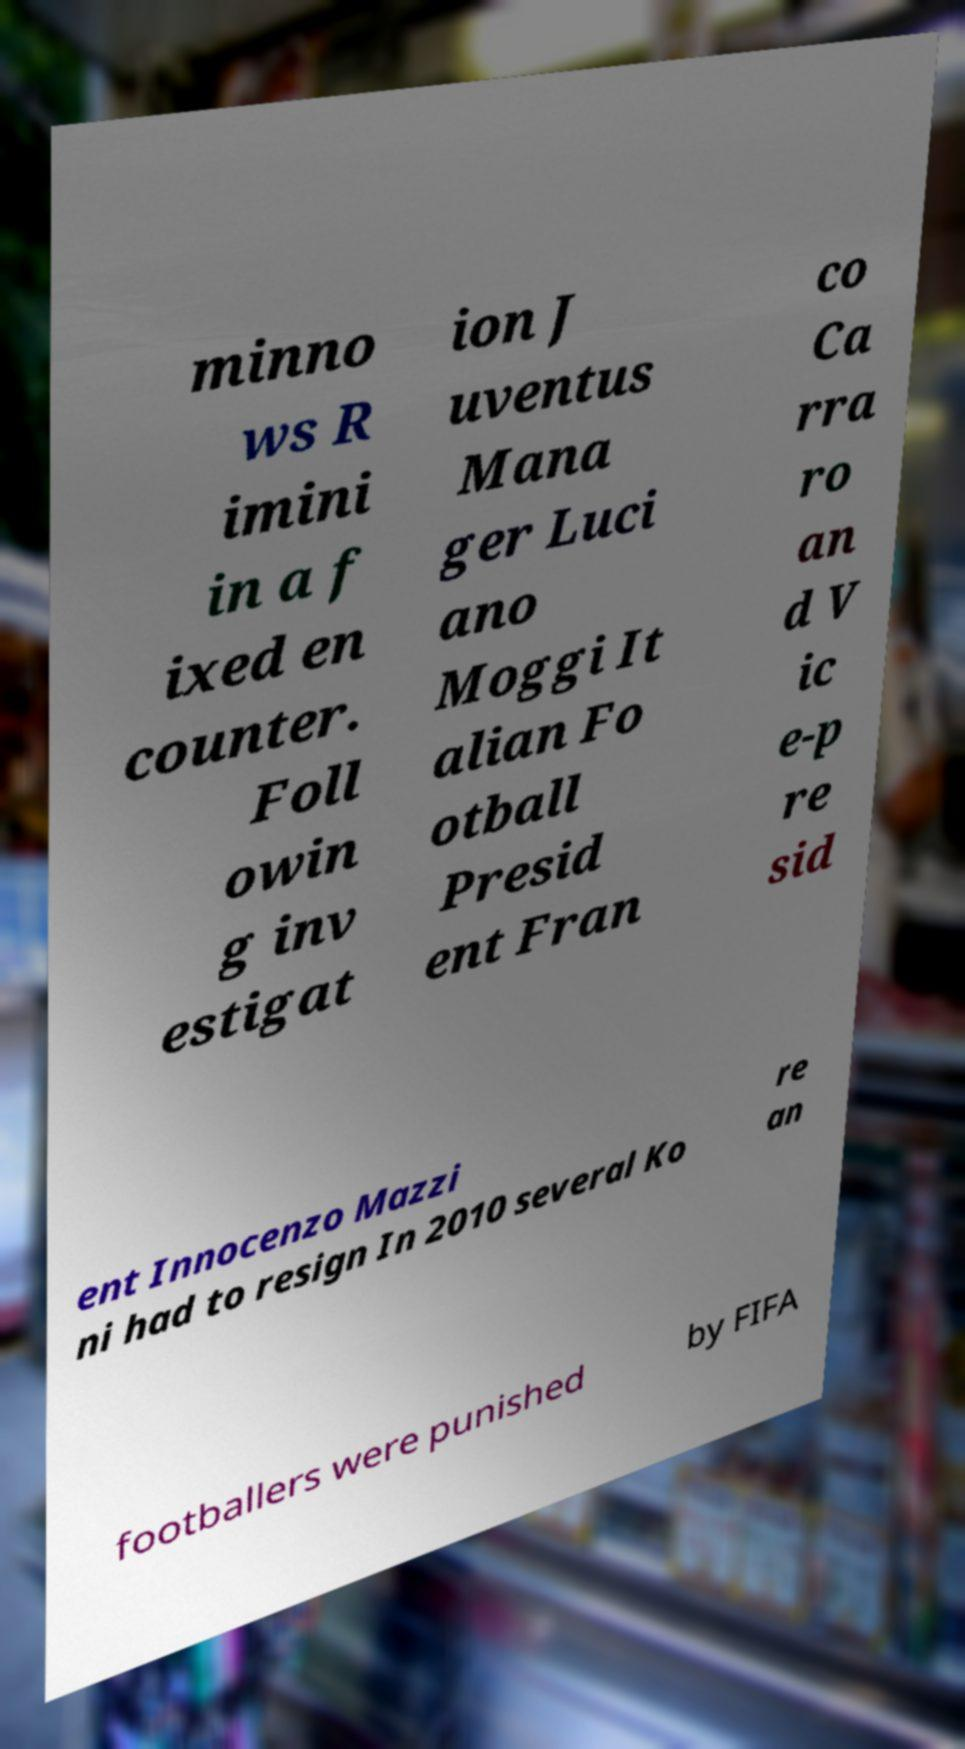Could you assist in decoding the text presented in this image and type it out clearly? minno ws R imini in a f ixed en counter. Foll owin g inv estigat ion J uventus Mana ger Luci ano Moggi It alian Fo otball Presid ent Fran co Ca rra ro an d V ic e-p re sid ent Innocenzo Mazzi ni had to resign In 2010 several Ko re an footballers were punished by FIFA 